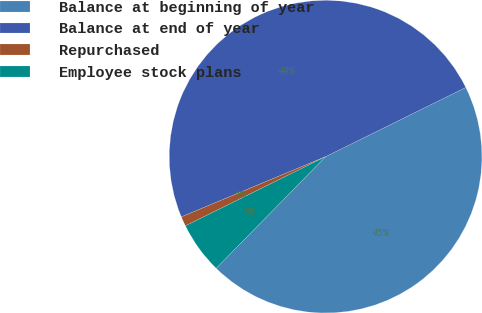<chart> <loc_0><loc_0><loc_500><loc_500><pie_chart><fcel>Balance at beginning of year<fcel>Balance at end of year<fcel>Repurchased<fcel>Employee stock plans<nl><fcel>44.64%<fcel>49.0%<fcel>1.0%<fcel>5.36%<nl></chart> 